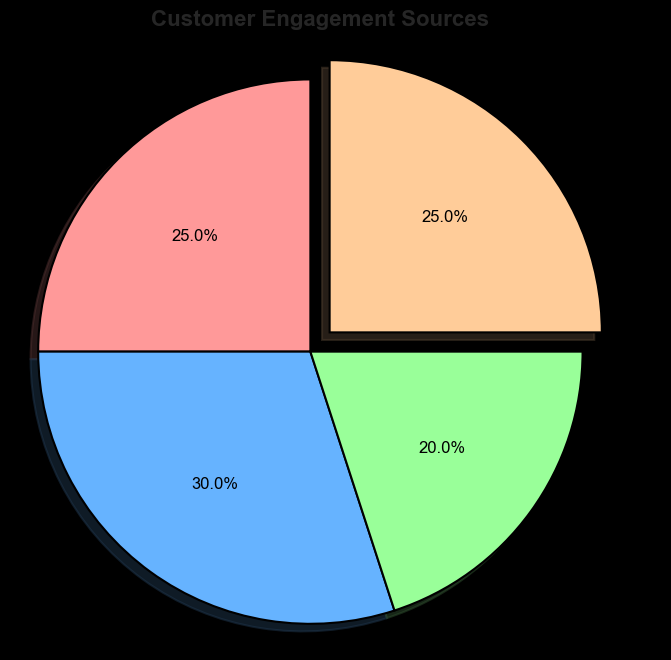What percentage of customer engagement comes from Video Marketing? The pie chart shows the percentage of customer engagement sources, and Video Marketing contributes to 25% of the total engagement.
Answer: 25% How does the percentage of customer engagement from Email compare to that from Social Media? From the pie chart, Email contributes to 25% and Social Media contributes to 30%, so Social Media has a higher engagement percentage than Email.
Answer: Social Media has a higher percentage Which engagement source has the least percentage, and what is it? By observing the pie chart, the Website contributes the least to customer engagement with a percentage of 20%.
Answer: Website, 20% What is the combined percentage of engagement from Email and Video Marketing? From the pie chart, both Email and Video Marketing contribute 25% each. Therefore, their combined engagement is 25% + 25% = 50%.
Answer: 50% Is there any source that's highlighted or exploded in the pie chart? The pie chart visually emphasizes Video Marketing by slightly exploding or separating that section from the others.
Answer: Yes, Video Marketing How much more does Social Media engagement contribute compared to Website engagement? Social Media has 30% engagement, and Website has 20% engagement. The difference is 30% - 20% = 10%.
Answer: 10% What is the average percentage of customer engagement across all sources? Adding the percentages: 25% (Email) + 30% (Social Media) + 20% (Website) + 25% (Video Marketing) = 100%. Dividing by the number of sources (4) gives the average: 100% / 4 = 25%.
Answer: 25% In terms of engagement, how do Video Marketing and Email compare, and what can be inferred from their percentages? Both Video Marketing and Email contribute equally to customer engagement at 25% each. This indicates that both methods are equally effective at engaging customers.
Answer: They contribute equally Which engagement source has the highest percentage, and what implications could this have? The pie chart reveals that Social Media has the highest engagement percentage at 30%. This suggests that social media efforts might be the most effective strategy for customer engagement for the business.
Answer: Social Media, 30% If engagement from the Website increased to match Email's percentage, what would be the new total engagement percentage from both? If Website engagement increased to 25% (matching Email's percentage), the new combined engagement from both sources would be 25% (Email) + 25% (Website) = 50%.
Answer: 50% 